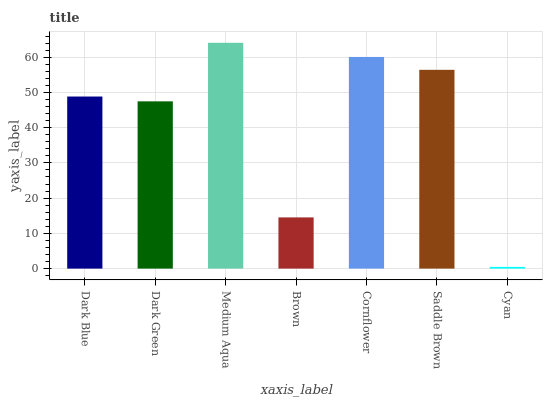Is Cyan the minimum?
Answer yes or no. Yes. Is Medium Aqua the maximum?
Answer yes or no. Yes. Is Dark Green the minimum?
Answer yes or no. No. Is Dark Green the maximum?
Answer yes or no. No. Is Dark Blue greater than Dark Green?
Answer yes or no. Yes. Is Dark Green less than Dark Blue?
Answer yes or no. Yes. Is Dark Green greater than Dark Blue?
Answer yes or no. No. Is Dark Blue less than Dark Green?
Answer yes or no. No. Is Dark Blue the high median?
Answer yes or no. Yes. Is Dark Blue the low median?
Answer yes or no. Yes. Is Medium Aqua the high median?
Answer yes or no. No. Is Cyan the low median?
Answer yes or no. No. 